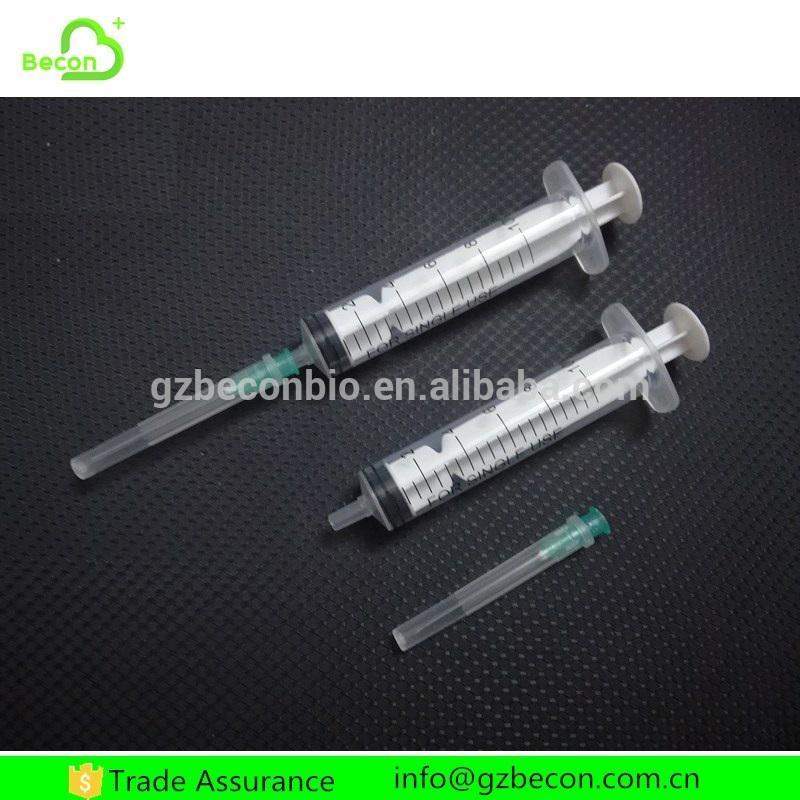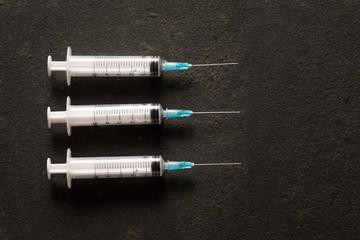The first image is the image on the left, the second image is the image on the right. Given the left and right images, does the statement "The right image has three syringes." hold true? Answer yes or no. Yes. The first image is the image on the left, the second image is the image on the right. Considering the images on both sides, is "Each image shows exactly three syringe-related items." valid? Answer yes or no. Yes. 